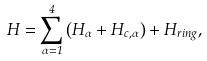Convert formula to latex. <formula><loc_0><loc_0><loc_500><loc_500>H = \sum _ { \alpha = 1 } ^ { 4 } \left ( H _ { \alpha } + H _ { c , \alpha } \right ) + H _ { r i n g } ,</formula> 